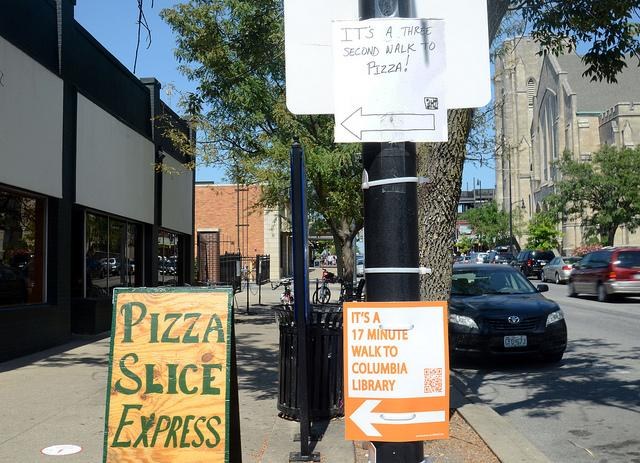What is the building across the street from the orange sign used for? pizza 